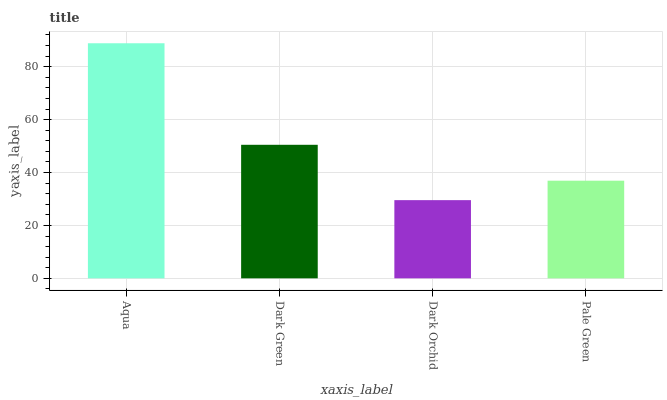Is Dark Orchid the minimum?
Answer yes or no. Yes. Is Aqua the maximum?
Answer yes or no. Yes. Is Dark Green the minimum?
Answer yes or no. No. Is Dark Green the maximum?
Answer yes or no. No. Is Aqua greater than Dark Green?
Answer yes or no. Yes. Is Dark Green less than Aqua?
Answer yes or no. Yes. Is Dark Green greater than Aqua?
Answer yes or no. No. Is Aqua less than Dark Green?
Answer yes or no. No. Is Dark Green the high median?
Answer yes or no. Yes. Is Pale Green the low median?
Answer yes or no. Yes. Is Aqua the high median?
Answer yes or no. No. Is Aqua the low median?
Answer yes or no. No. 